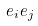<formula> <loc_0><loc_0><loc_500><loc_500>e _ { i } e _ { j }</formula> 